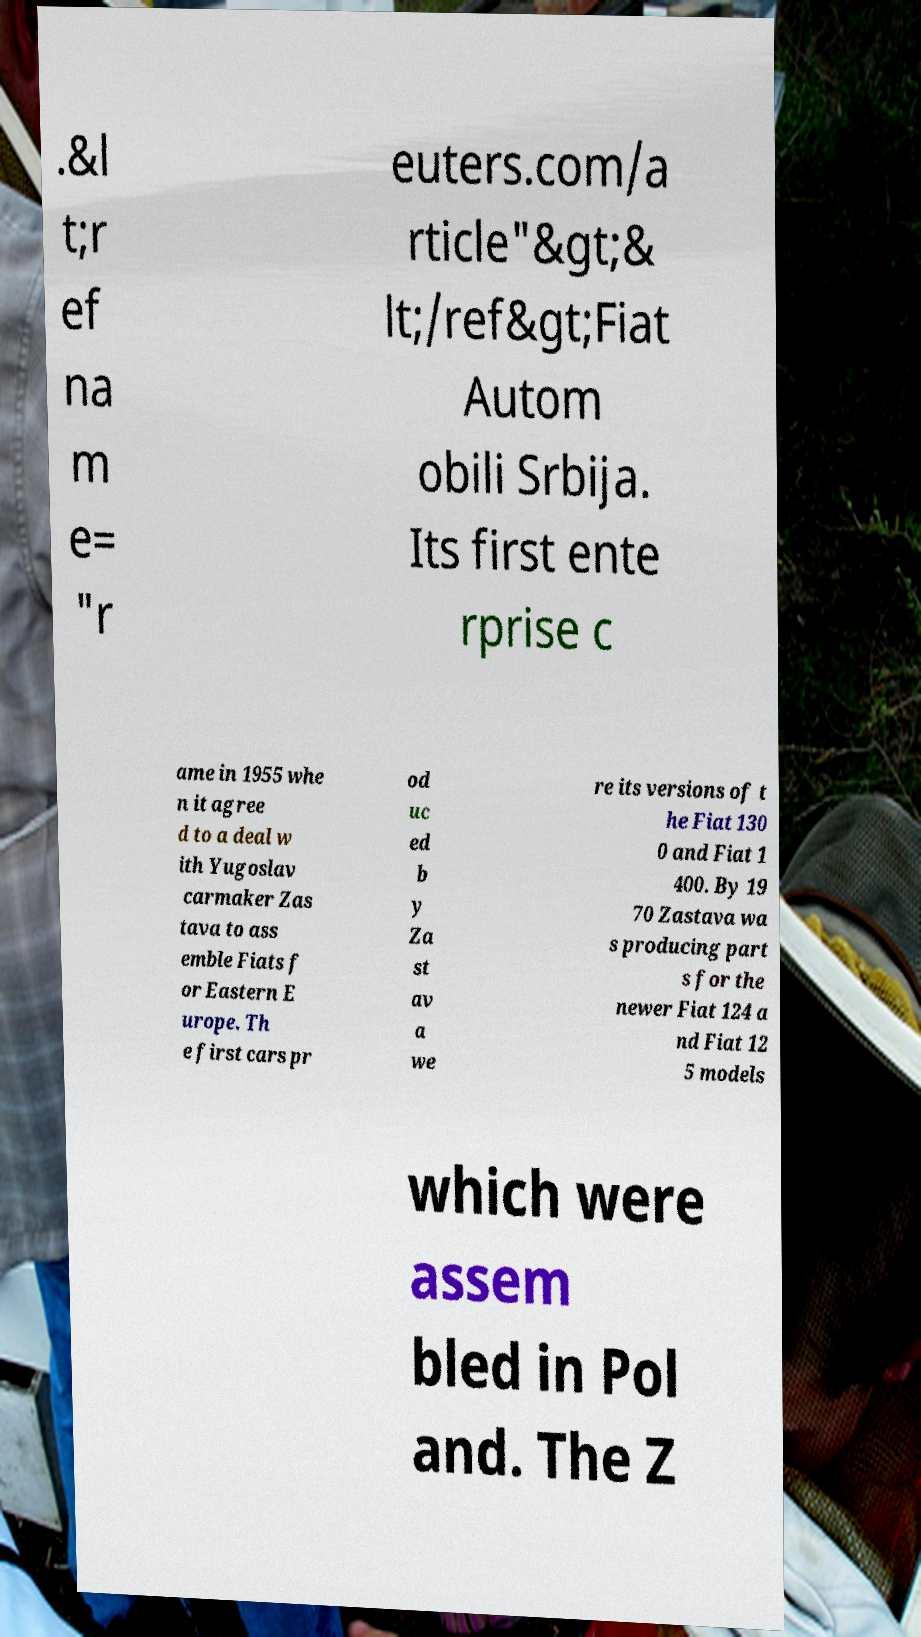Please read and relay the text visible in this image. What does it say? .&l t;r ef na m e= "r euters.com/a rticle"&gt;& lt;/ref&gt;Fiat Autom obili Srbija. Its first ente rprise c ame in 1955 whe n it agree d to a deal w ith Yugoslav carmaker Zas tava to ass emble Fiats f or Eastern E urope. Th e first cars pr od uc ed b y Za st av a we re its versions of t he Fiat 130 0 and Fiat 1 400. By 19 70 Zastava wa s producing part s for the newer Fiat 124 a nd Fiat 12 5 models which were assem bled in Pol and. The Z 